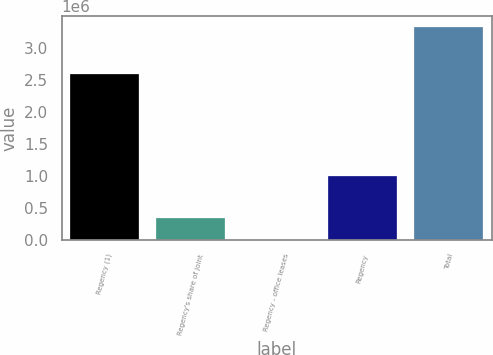<chart> <loc_0><loc_0><loc_500><loc_500><bar_chart><fcel>Regency (1)<fcel>Regency's share of joint<fcel>Regency - office leases<fcel>Regency<fcel>Total<nl><fcel>2.58634e+06<fcel>339787<fcel>8155<fcel>1.00305e+06<fcel>3.32448e+06<nl></chart> 